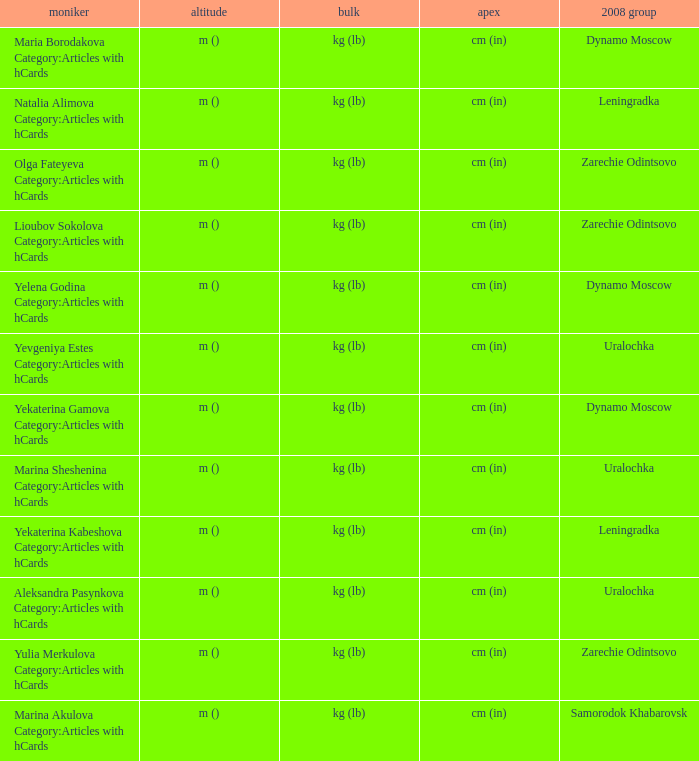What is the name when the 2008 club is zarechie odintsovo? Olga Fateyeva Category:Articles with hCards, Lioubov Sokolova Category:Articles with hCards, Yulia Merkulova Category:Articles with hCards. 